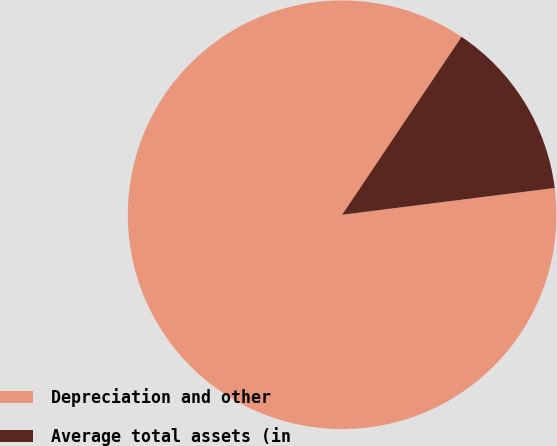<chart> <loc_0><loc_0><loc_500><loc_500><pie_chart><fcel>Depreciation and other<fcel>Average total assets (in<nl><fcel>86.4%<fcel>13.6%<nl></chart> 